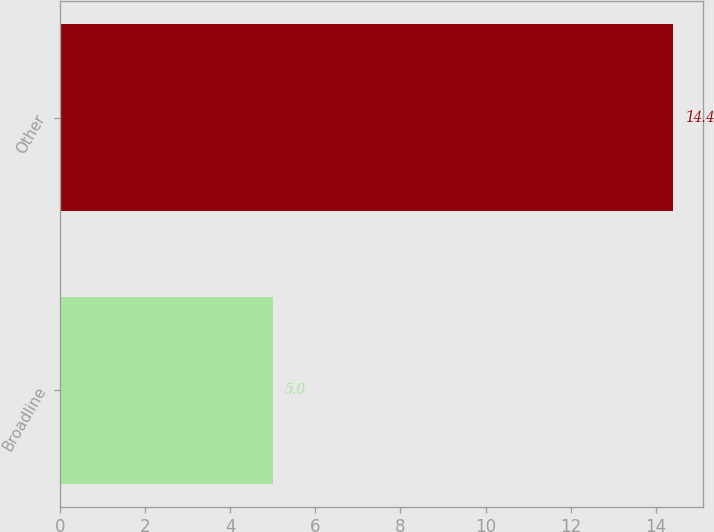<chart> <loc_0><loc_0><loc_500><loc_500><bar_chart><fcel>Broadline<fcel>Other<nl><fcel>5<fcel>14.4<nl></chart> 